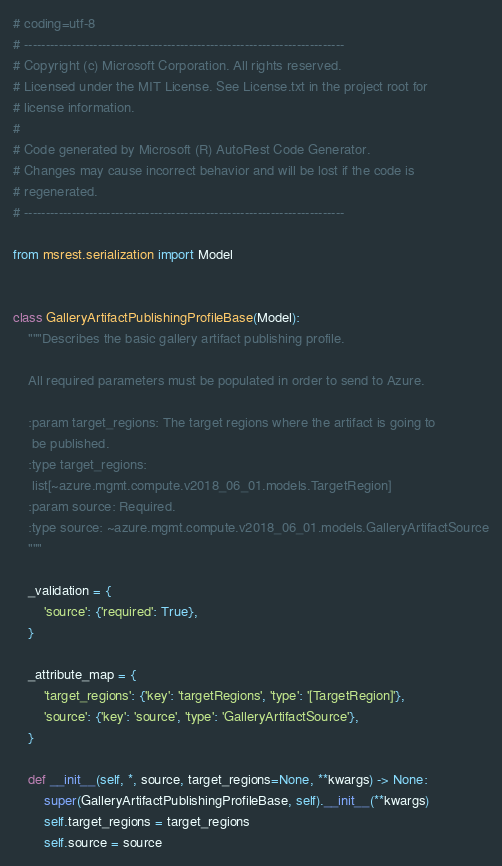Convert code to text. <code><loc_0><loc_0><loc_500><loc_500><_Python_># coding=utf-8
# --------------------------------------------------------------------------
# Copyright (c) Microsoft Corporation. All rights reserved.
# Licensed under the MIT License. See License.txt in the project root for
# license information.
#
# Code generated by Microsoft (R) AutoRest Code Generator.
# Changes may cause incorrect behavior and will be lost if the code is
# regenerated.
# --------------------------------------------------------------------------

from msrest.serialization import Model


class GalleryArtifactPublishingProfileBase(Model):
    """Describes the basic gallery artifact publishing profile.

    All required parameters must be populated in order to send to Azure.

    :param target_regions: The target regions where the artifact is going to
     be published.
    :type target_regions:
     list[~azure.mgmt.compute.v2018_06_01.models.TargetRegion]
    :param source: Required.
    :type source: ~azure.mgmt.compute.v2018_06_01.models.GalleryArtifactSource
    """

    _validation = {
        'source': {'required': True},
    }

    _attribute_map = {
        'target_regions': {'key': 'targetRegions', 'type': '[TargetRegion]'},
        'source': {'key': 'source', 'type': 'GalleryArtifactSource'},
    }

    def __init__(self, *, source, target_regions=None, **kwargs) -> None:
        super(GalleryArtifactPublishingProfileBase, self).__init__(**kwargs)
        self.target_regions = target_regions
        self.source = source
</code> 